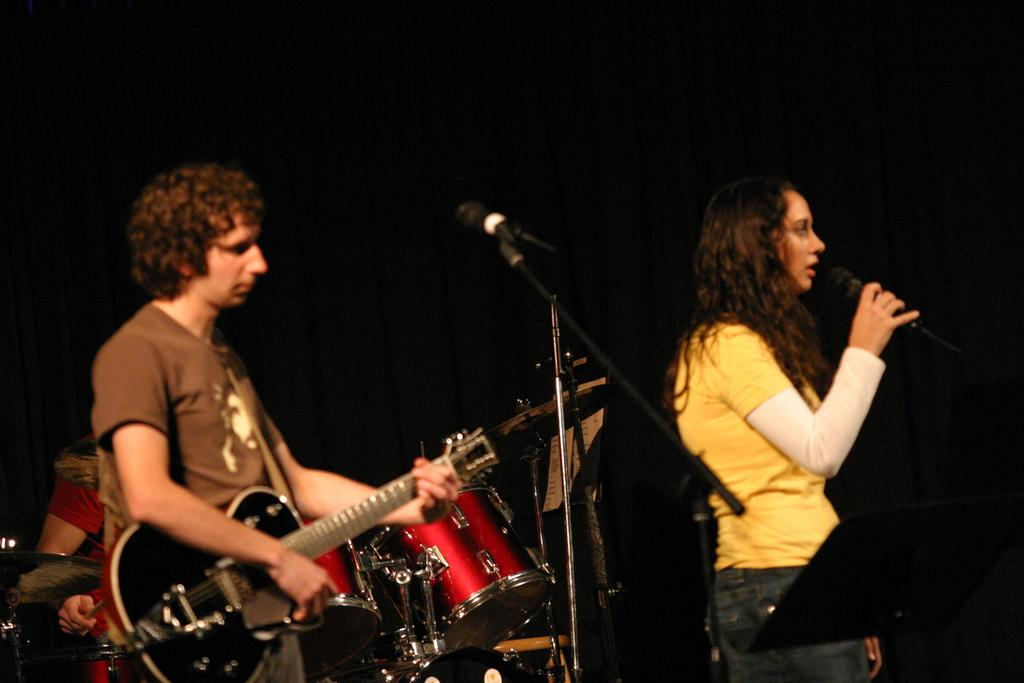How many people are in the image? There are two persons in the image. Can you describe the lady in the image? One of the persons is a lady, and she is singing. What is the other person doing in the image? The other person is playing a guitar. Are there any musical instruments visible in the image? Yes, there are musical instruments visible in the background. What type of cork can be seen in the image? There is no cork present in the image. How does the lady's anger affect her singing in the image? The lady's emotions, including anger, are not mentioned or depicted in the image, so we cannot determine how they might affect her singing. 